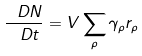<formula> <loc_0><loc_0><loc_500><loc_500>\frac { \ D N } { \ D t } = V \sum _ { \rho } \gamma _ { \rho } r _ { \rho }</formula> 